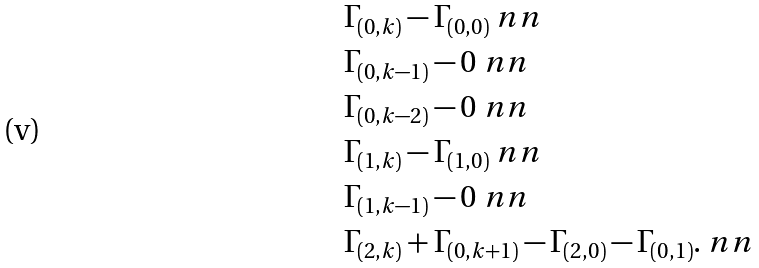<formula> <loc_0><loc_0><loc_500><loc_500>& \Gamma _ { ( 0 , k ) } - \Gamma _ { ( 0 , 0 ) } \ n n \\ & \Gamma _ { ( 0 , k - 1 ) } - 0 \ n n \\ & \Gamma _ { ( 0 , k - 2 ) } - 0 \ n n \\ & \Gamma _ { ( 1 , k ) } - \Gamma _ { ( 1 , 0 ) } \ n n \\ & \Gamma _ { ( 1 , k - 1 ) } - 0 \ n n \\ & \Gamma _ { ( 2 , k ) } + \Gamma _ { ( 0 , k + 1 ) } - \Gamma _ { ( 2 , 0 ) } - \Gamma _ { ( 0 , 1 ) } . \ n n</formula> 